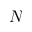Convert formula to latex. <formula><loc_0><loc_0><loc_500><loc_500>N</formula> 